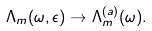Convert formula to latex. <formula><loc_0><loc_0><loc_500><loc_500>\Lambda _ { m } ( \omega , \epsilon ) \rightarrow \Lambda _ { m } ^ { ( a ) } ( \omega ) .</formula> 